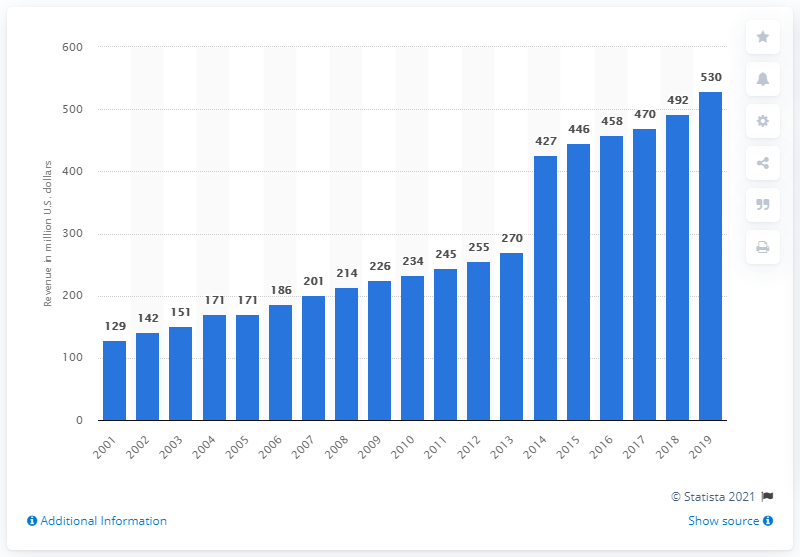Outline some significant characteristics in this image. The revenue of the San Francisco 49ers in 2019 was $530 million. 